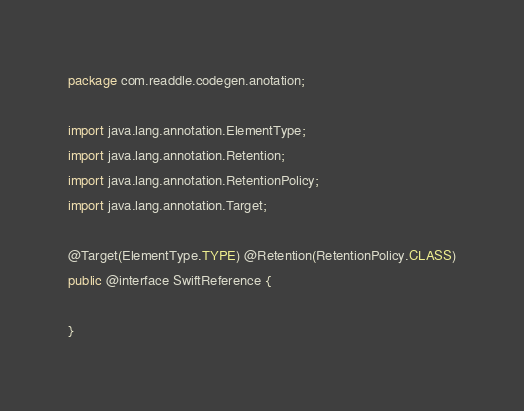Convert code to text. <code><loc_0><loc_0><loc_500><loc_500><_Java_>package com.readdle.codegen.anotation;

import java.lang.annotation.ElementType;
import java.lang.annotation.Retention;
import java.lang.annotation.RetentionPolicy;
import java.lang.annotation.Target;

@Target(ElementType.TYPE) @Retention(RetentionPolicy.CLASS)
public @interface SwiftReference {

}
</code> 